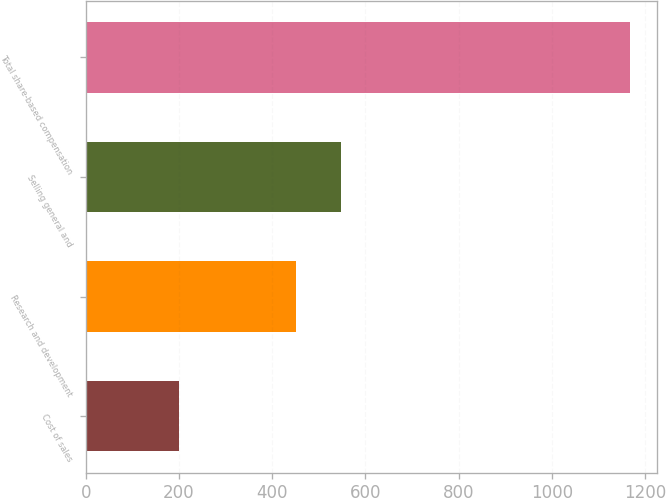<chart> <loc_0><loc_0><loc_500><loc_500><bar_chart><fcel>Cost of sales<fcel>Research and development<fcel>Selling general and<fcel>Total share-based compensation<nl><fcel>200<fcel>450<fcel>546.8<fcel>1168<nl></chart> 